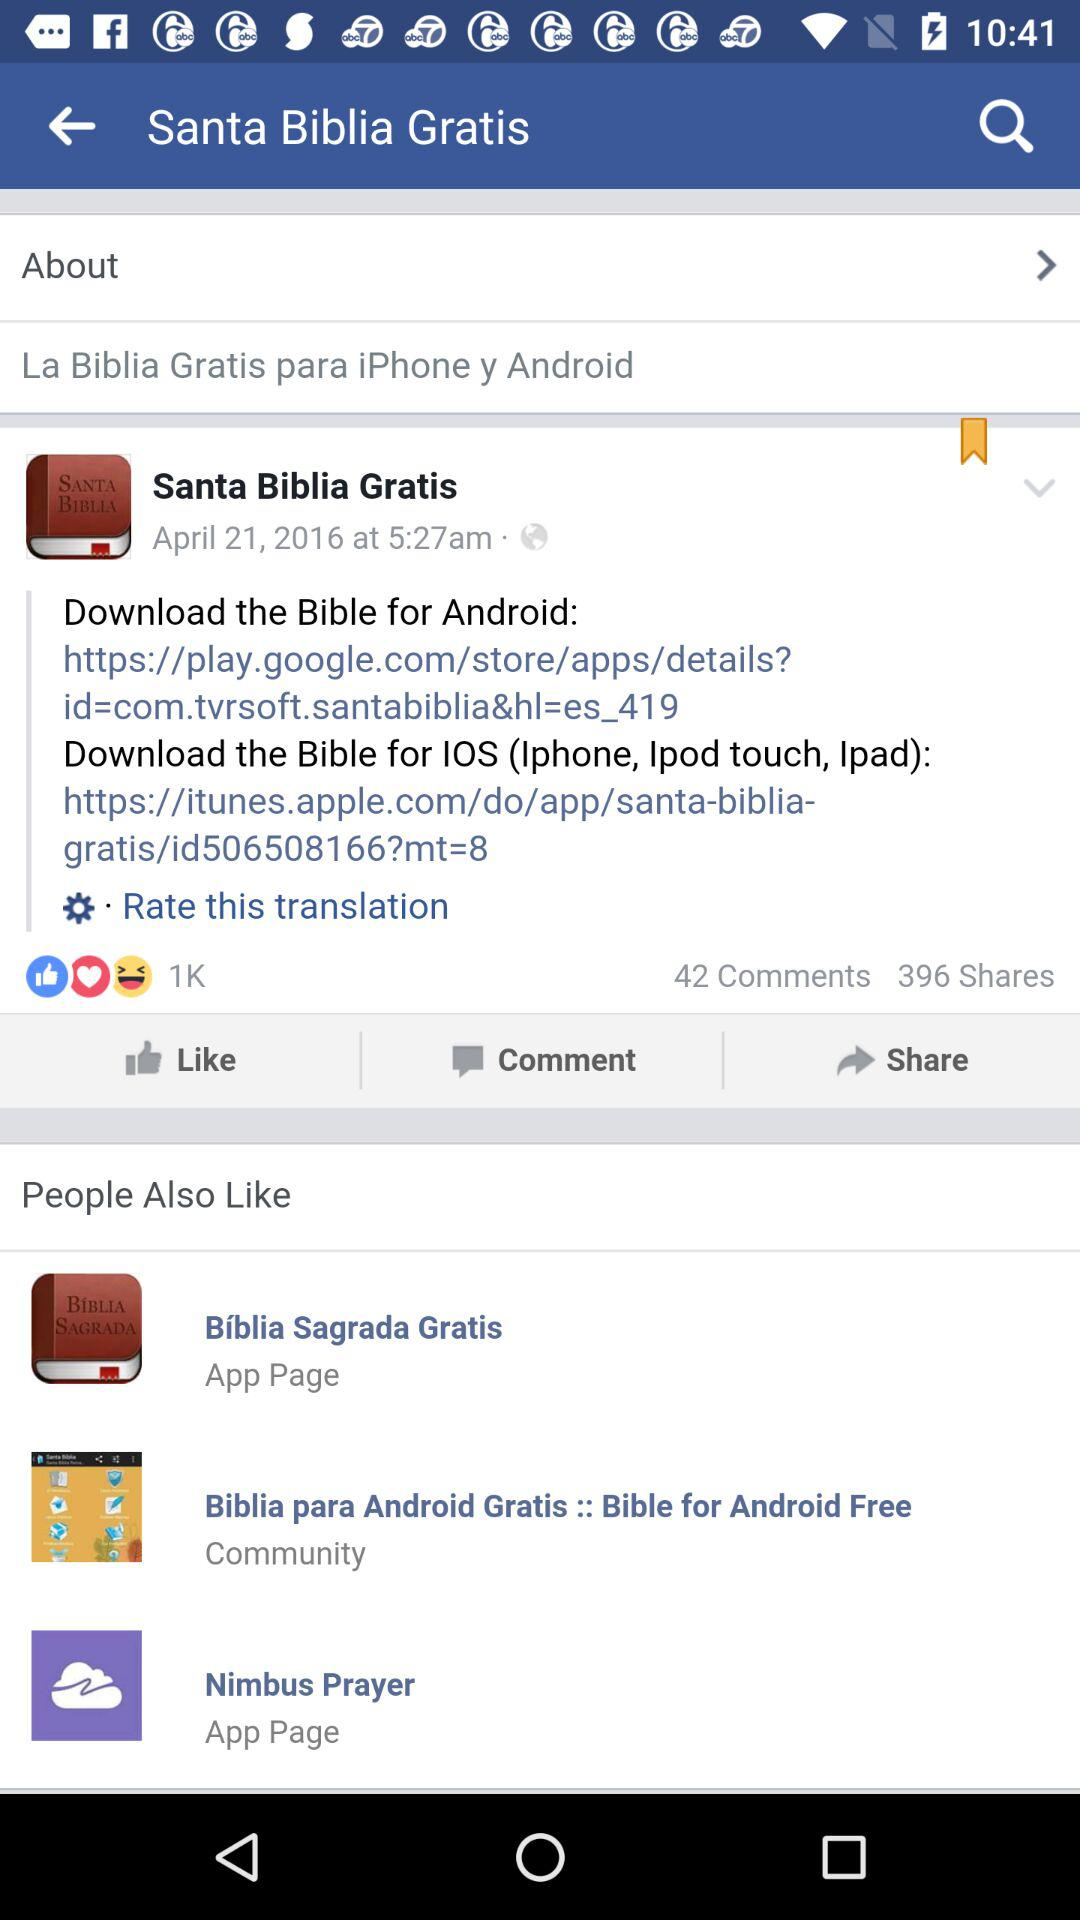How many people have liked the post? There are 1K people who have liked the post. 